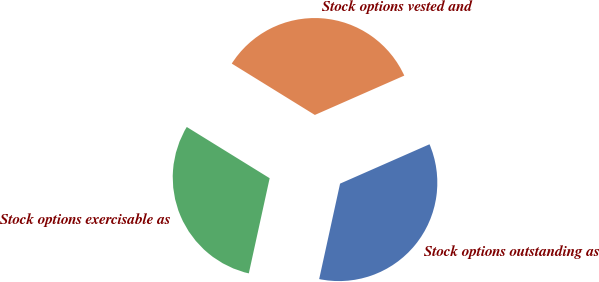Convert chart to OTSL. <chart><loc_0><loc_0><loc_500><loc_500><pie_chart><fcel>Stock options outstanding as<fcel>Stock options vested and<fcel>Stock options exercisable as<nl><fcel>35.03%<fcel>34.59%<fcel>30.38%<nl></chart> 